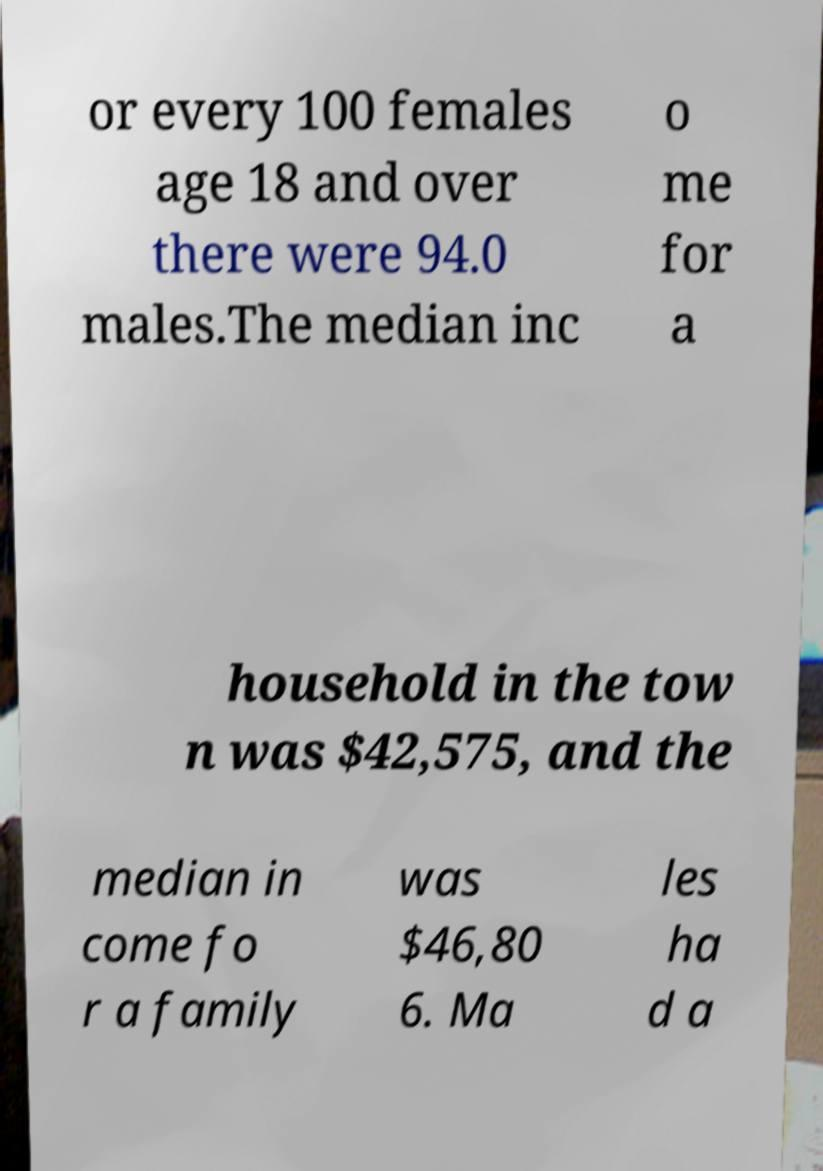For documentation purposes, I need the text within this image transcribed. Could you provide that? or every 100 females age 18 and over there were 94.0 males.The median inc o me for a household in the tow n was $42,575, and the median in come fo r a family was $46,80 6. Ma les ha d a 